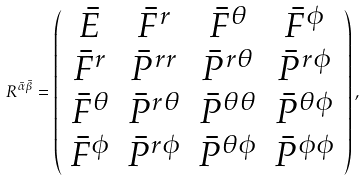<formula> <loc_0><loc_0><loc_500><loc_500>R ^ { \bar { \alpha } \bar { \beta } } = \left ( \begin{array} { c c c c } \bar { E } & \bar { F } ^ { r } & \bar { F } ^ { \theta } & \bar { F } ^ { \phi } \\ \bar { F } ^ { r } & \bar { P } ^ { r r } & \bar { P } ^ { r \theta } & \bar { P } ^ { r \phi } \\ \bar { F } ^ { \theta } & \bar { P } ^ { r \theta } & \bar { P } ^ { \theta \theta } & \bar { P } ^ { \theta \phi } \\ \bar { F } ^ { \phi } & \bar { P } ^ { r \phi } & \bar { P } ^ { \theta \phi } & \bar { P } ^ { \phi \phi } \end{array} \right ) ,</formula> 